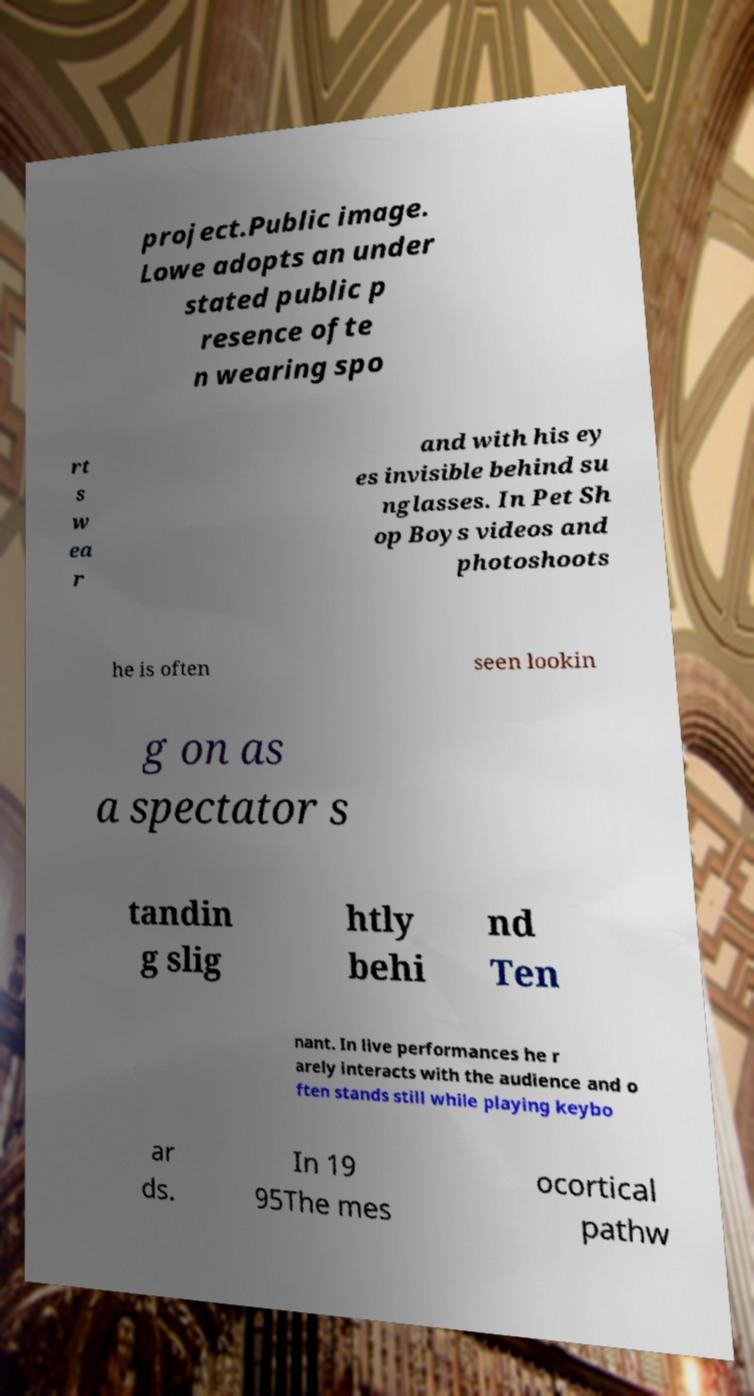For documentation purposes, I need the text within this image transcribed. Could you provide that? project.Public image. Lowe adopts an under stated public p resence ofte n wearing spo rt s w ea r and with his ey es invisible behind su nglasses. In Pet Sh op Boys videos and photoshoots he is often seen lookin g on as a spectator s tandin g slig htly behi nd Ten nant. In live performances he r arely interacts with the audience and o ften stands still while playing keybo ar ds. In 19 95The mes ocortical pathw 